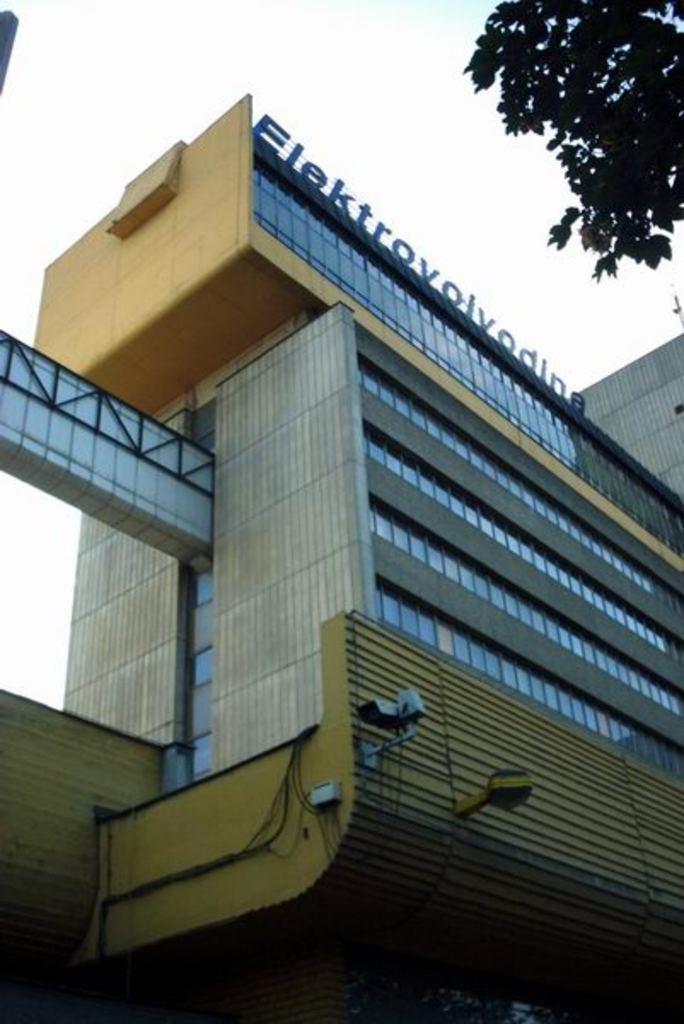Describe this image in one or two sentences. In this image we can see building with glass walls. On the top of the building something is written. In the background there is sky. At the top right corner we can see branches of a tree. 